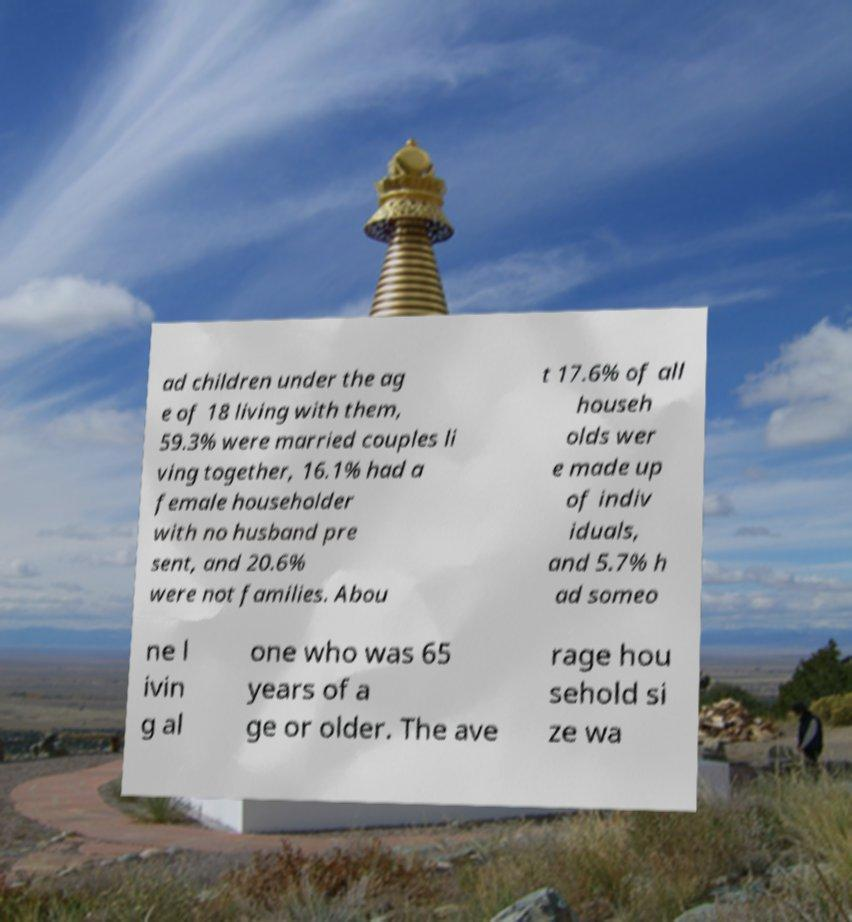Could you extract and type out the text from this image? ad children under the ag e of 18 living with them, 59.3% were married couples li ving together, 16.1% had a female householder with no husband pre sent, and 20.6% were not families. Abou t 17.6% of all househ olds wer e made up of indiv iduals, and 5.7% h ad someo ne l ivin g al one who was 65 years of a ge or older. The ave rage hou sehold si ze wa 